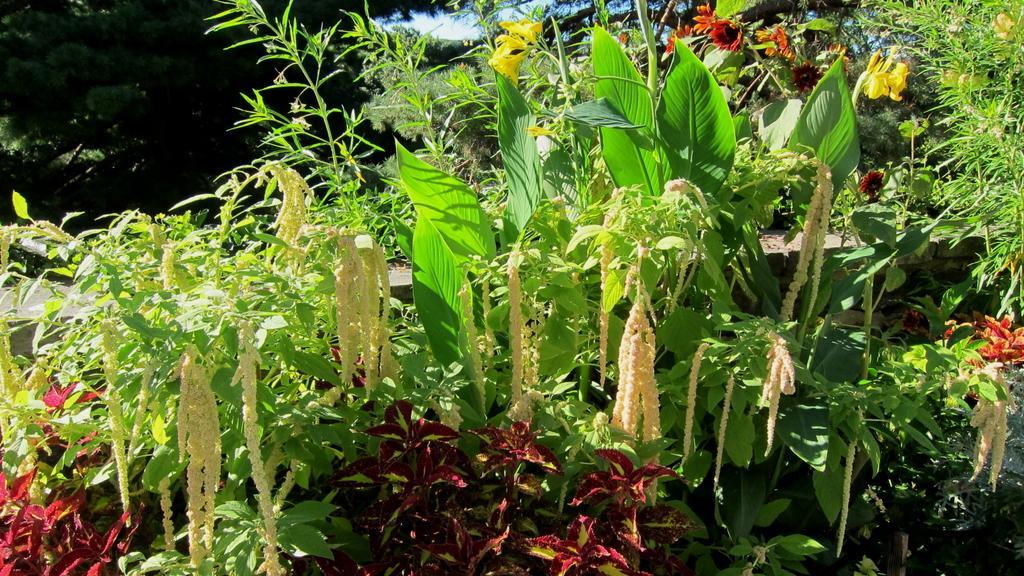Describe this image in one or two sentences. In this picture we can see flowers, plants, trees and in the background we can see the sky. 